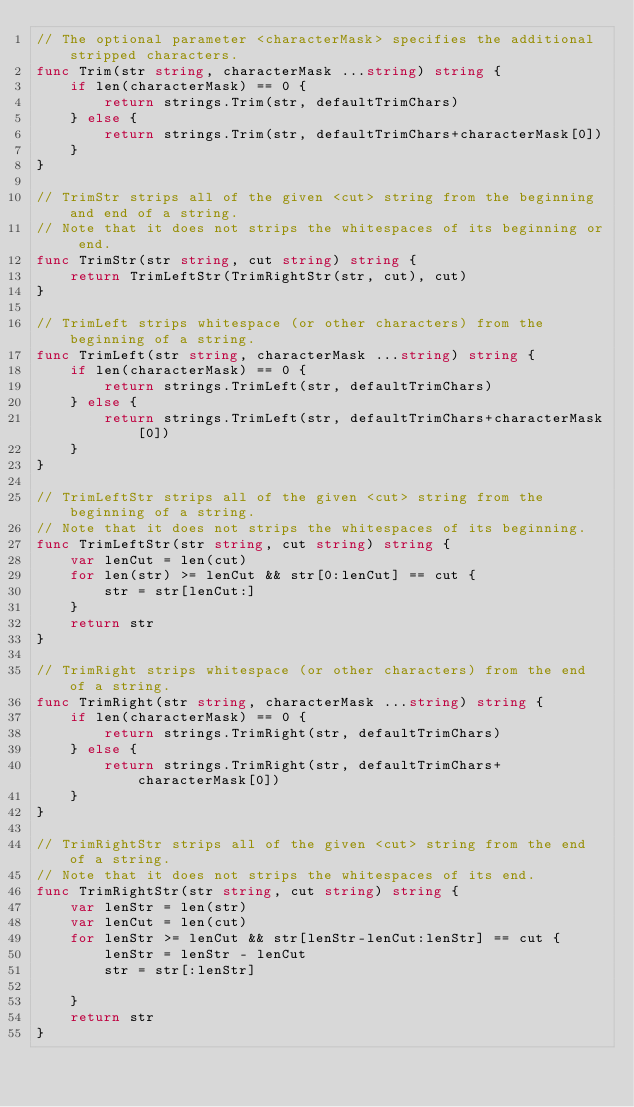<code> <loc_0><loc_0><loc_500><loc_500><_Go_>// The optional parameter <characterMask> specifies the additional stripped characters.
func Trim(str string, characterMask ...string) string {
	if len(characterMask) == 0 {
		return strings.Trim(str, defaultTrimChars)
	} else {
		return strings.Trim(str, defaultTrimChars+characterMask[0])
	}
}

// TrimStr strips all of the given <cut> string from the beginning and end of a string.
// Note that it does not strips the whitespaces of its beginning or end.
func TrimStr(str string, cut string) string {
	return TrimLeftStr(TrimRightStr(str, cut), cut)
}

// TrimLeft strips whitespace (or other characters) from the beginning of a string.
func TrimLeft(str string, characterMask ...string) string {
	if len(characterMask) == 0 {
		return strings.TrimLeft(str, defaultTrimChars)
	} else {
		return strings.TrimLeft(str, defaultTrimChars+characterMask[0])
	}
}

// TrimLeftStr strips all of the given <cut> string from the beginning of a string.
// Note that it does not strips the whitespaces of its beginning.
func TrimLeftStr(str string, cut string) string {
	var lenCut = len(cut)
	for len(str) >= lenCut && str[0:lenCut] == cut {
		str = str[lenCut:]
	}
	return str
}

// TrimRight strips whitespace (or other characters) from the end of a string.
func TrimRight(str string, characterMask ...string) string {
	if len(characterMask) == 0 {
		return strings.TrimRight(str, defaultTrimChars)
	} else {
		return strings.TrimRight(str, defaultTrimChars+characterMask[0])
	}
}

// TrimRightStr strips all of the given <cut> string from the end of a string.
// Note that it does not strips the whitespaces of its end.
func TrimRightStr(str string, cut string) string {
	var lenStr = len(str)
	var lenCut = len(cut)
	for lenStr >= lenCut && str[lenStr-lenCut:lenStr] == cut {
		lenStr = lenStr - lenCut
		str = str[:lenStr]

	}
	return str
}
</code> 